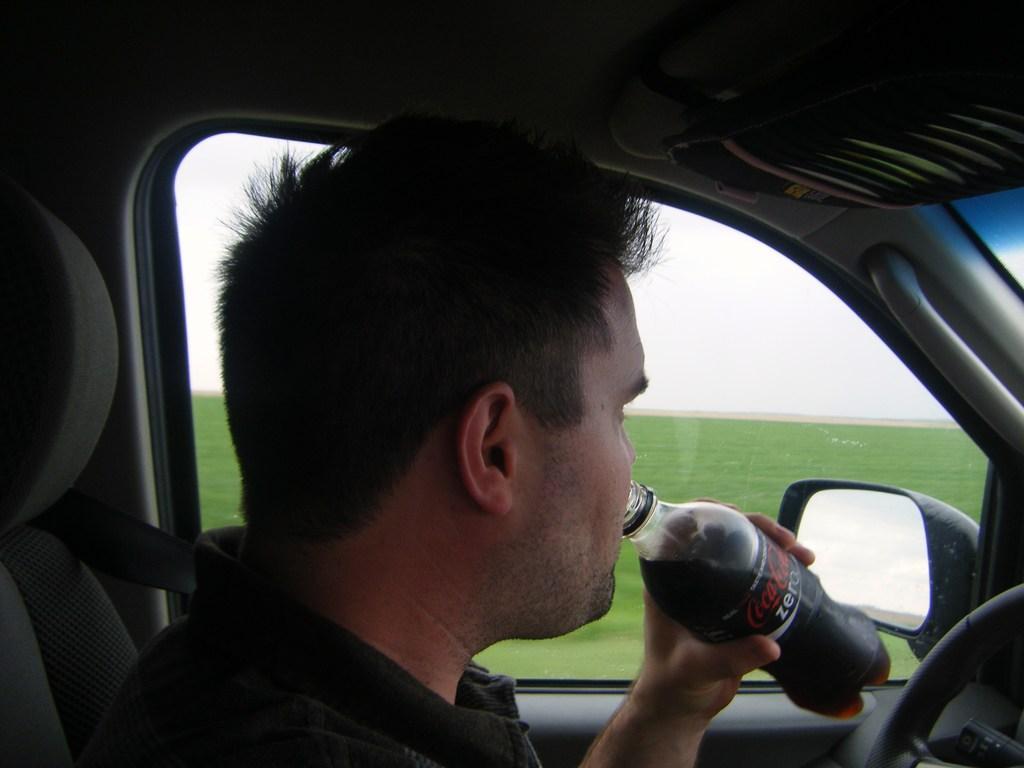Please provide a concise description of this image. I could see a person drinking coca cola with bottle he is inside the car holding a steering. In the back ground i could see the green colored grass and cloudy sky. 